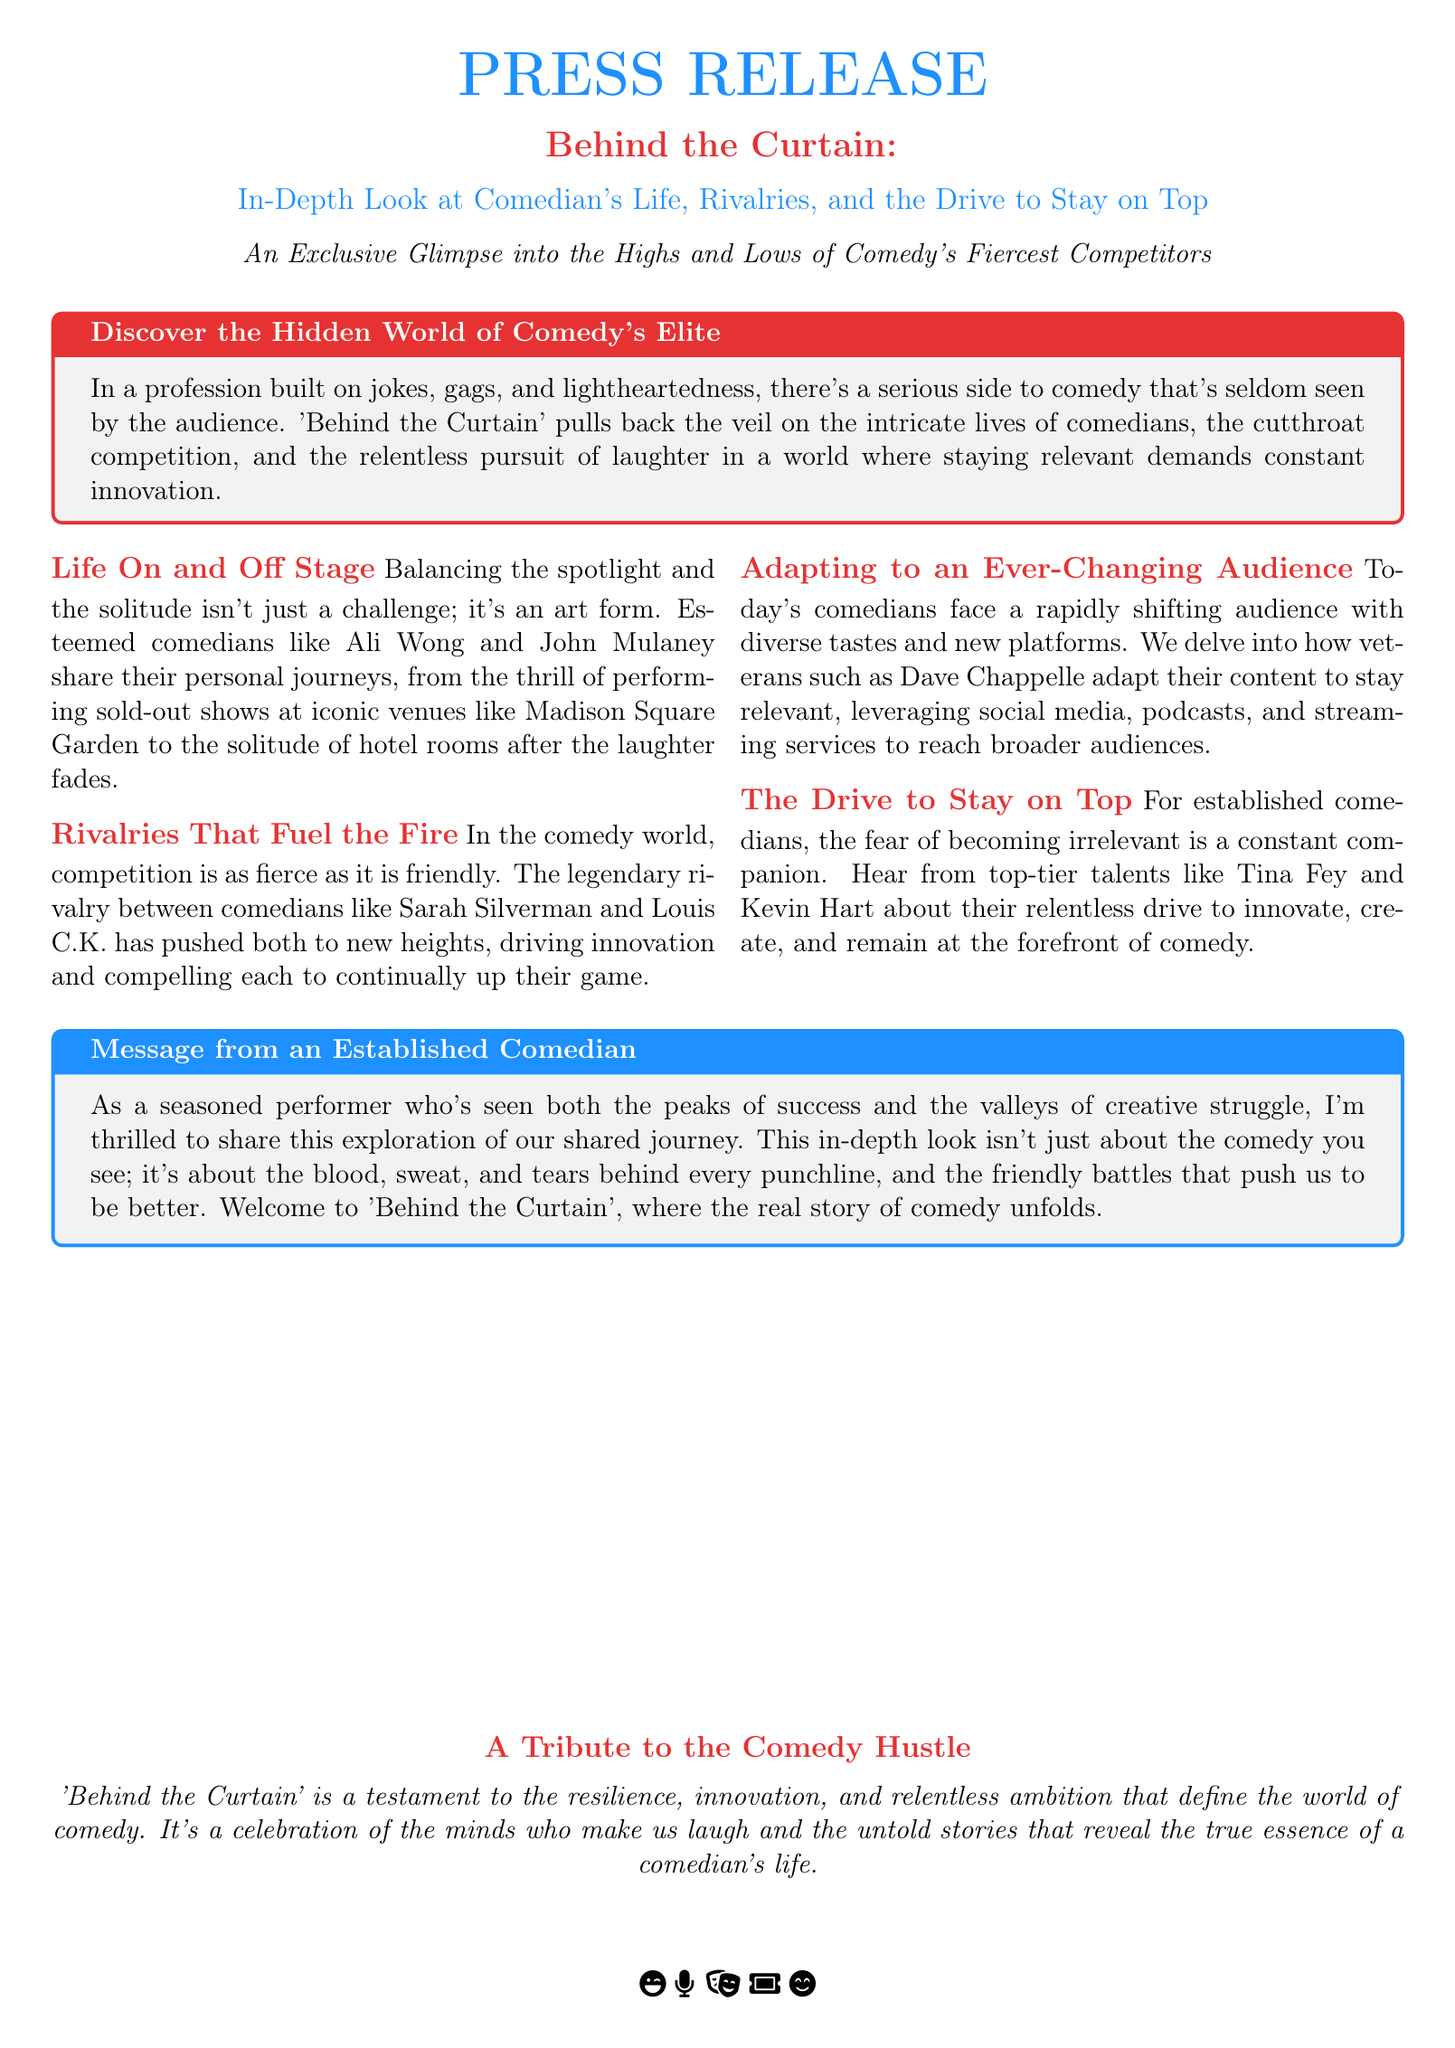What is the title of the press release? The title of the press release is the main heading at the top of the document, which introduces the subject matter of the release.
Answer: Behind the Curtain Which comedians are mentioned in the press release? The press release highlights several comedians and their experiences, which are listed within the document.
Answer: Ali Wong, John Mulaney, Sarah Silverman, Louis C.K., Dave Chappelle, Tina Fey, Kevin Hart What does 'Behind the Curtain' focus on? The press release outlines the main themes of the documentary, particularly what it explores about the comedy industry.
Answer: Comedian’s Life, Rivalries, and the Drive to Stay on Top What type of performances do comedians like Ali Wong and John Mulaney engage in? The press release describes the nature of performances that comedians participate in, providing context for their public life.
Answer: Sold-out shows Which rivalry is mentioned as pushing comedians to new heights? The press release specifically refers to a competition between well-known comedians that drives their creative output.
Answer: Sarah Silverman and Louis C.K What is a central theme expressed by established comedians in the documentary? The press release encapsulates the underlying message from veteran comedians about their profession and its challenges.
Answer: Fear of becoming irrelevant 